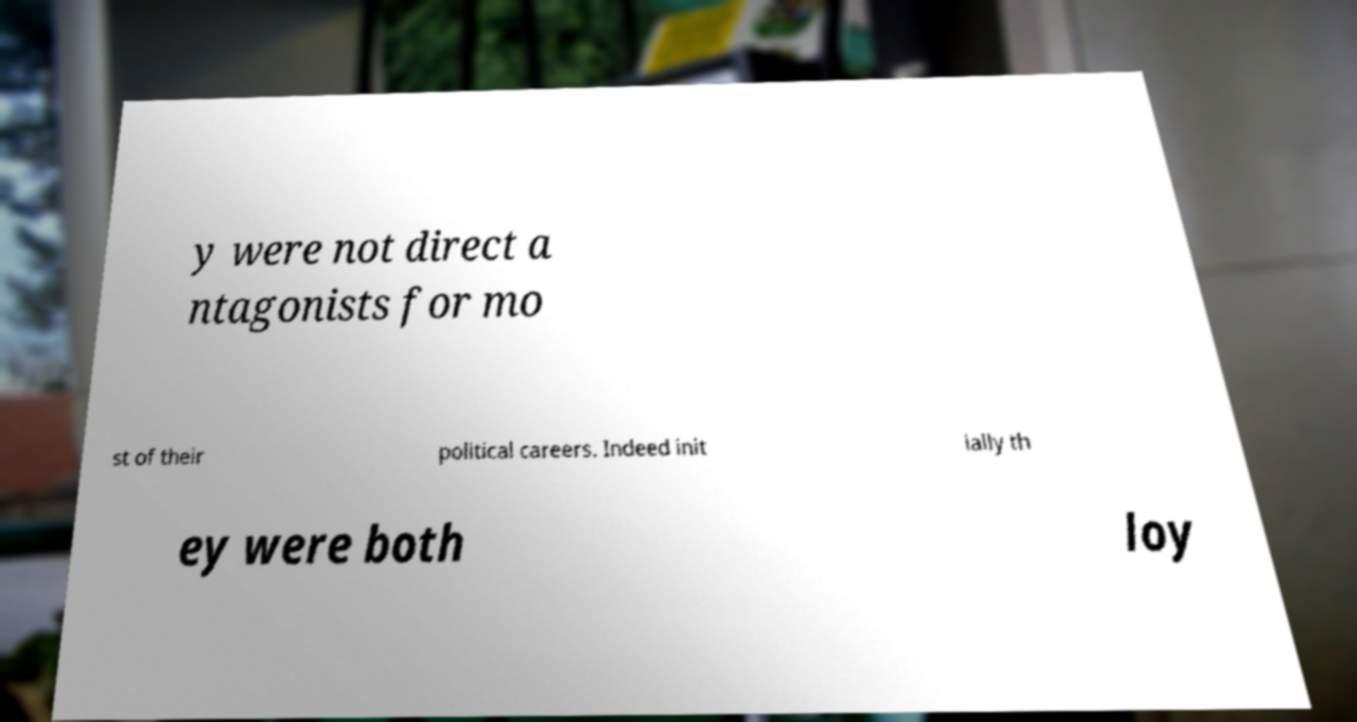Could you assist in decoding the text presented in this image and type it out clearly? y were not direct a ntagonists for mo st of their political careers. Indeed init ially th ey were both loy 